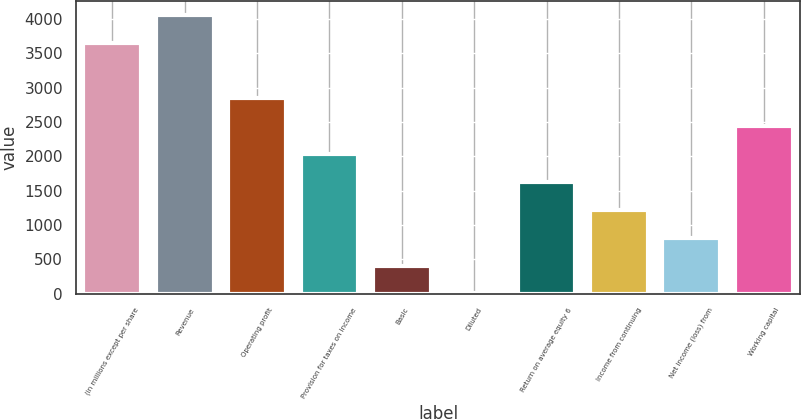Convert chart. <chart><loc_0><loc_0><loc_500><loc_500><bar_chart><fcel>(in millions except per share<fcel>Revenue<fcel>Operating profit<fcel>Provision for taxes on income<fcel>Basic<fcel>Diluted<fcel>Return on average equity 6<fcel>Income from continuing<fcel>Net income (loss) from<fcel>Working capital<nl><fcel>3655.12<fcel>4061.03<fcel>2843.3<fcel>2031.48<fcel>407.86<fcel>1.95<fcel>1625.58<fcel>1219.67<fcel>813.77<fcel>2437.39<nl></chart> 